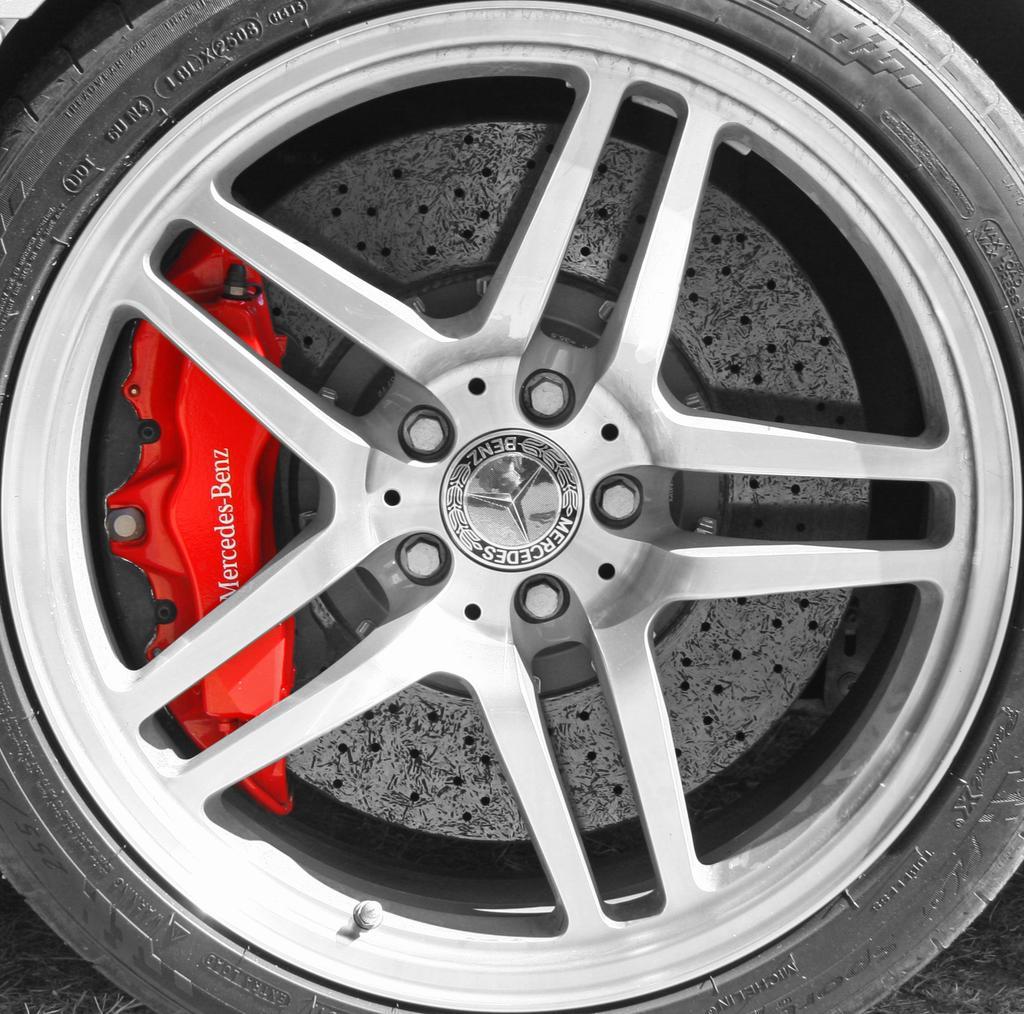Could you give a brief overview of what you see in this image? Here in this picture we can see a wheel of the car with Tyre on it over there. 